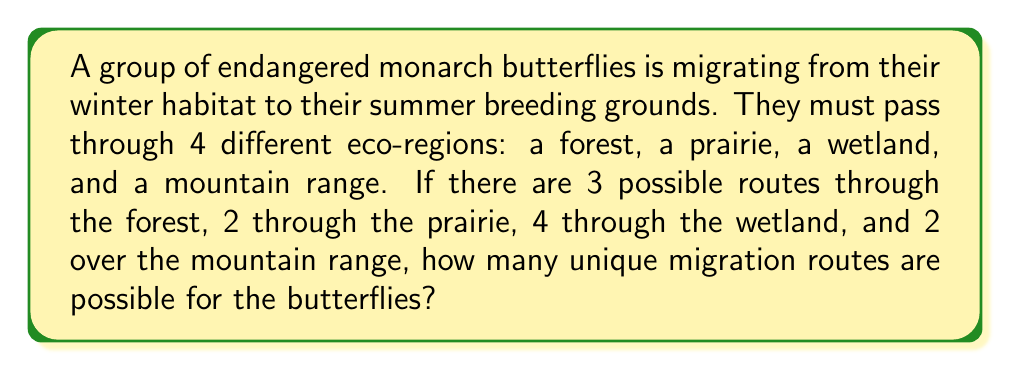Help me with this question. To solve this problem, we'll use the multiplication principle of counting. This principle states that if we have a sequence of choices, and the number of ways of making each choice is independent of the other choices, then the total number of ways to make all the choices is the product of the number of ways for each individual choice.

Let's break it down step-by-step:

1. Forest routes: 3 options
2. Prairie routes: 2 options
3. Wetland routes: 4 options
4. Mountain range routes: 2 options

Since the butterflies must pass through all four eco-regions, and the choice of route in one region doesn't affect the choices in the others, we multiply the number of options for each region:

$$ \text{Total routes} = 3 \times 2 \times 4 \times 2 $$

$$ = 48 $$

Therefore, there are 48 unique migration routes possible for the butterflies.

This calculation demonstrates how even a small number of choices in each stage can lead to a significant number of total possibilities, highlighting the complexity of wildlife migration patterns and the importance of preserving multiple habitats and corridors for endangered species.
Answer: 48 routes 